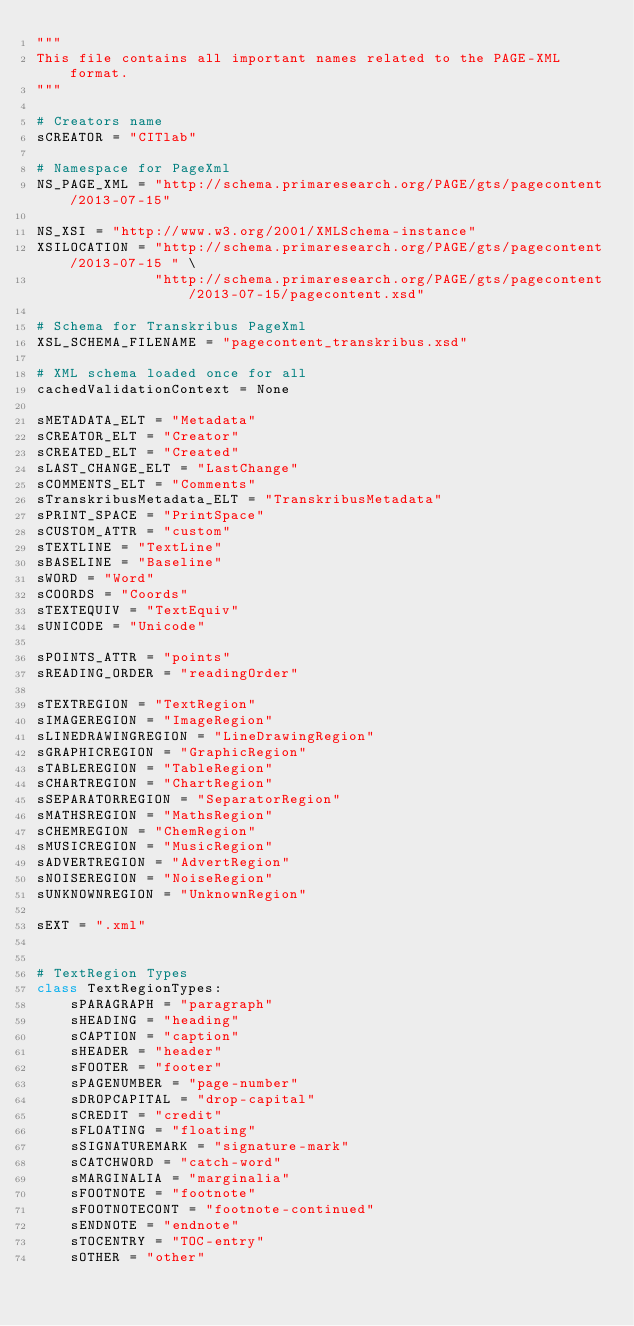Convert code to text. <code><loc_0><loc_0><loc_500><loc_500><_Python_>"""
This file contains all important names related to the PAGE-XML format.
"""

# Creators name
sCREATOR = "CITlab"

# Namespace for PageXml
NS_PAGE_XML = "http://schema.primaresearch.org/PAGE/gts/pagecontent/2013-07-15"

NS_XSI = "http://www.w3.org/2001/XMLSchema-instance"
XSILOCATION = "http://schema.primaresearch.org/PAGE/gts/pagecontent/2013-07-15 " \
              "http://schema.primaresearch.org/PAGE/gts/pagecontent/2013-07-15/pagecontent.xsd"

# Schema for Transkribus PageXml
XSL_SCHEMA_FILENAME = "pagecontent_transkribus.xsd"

# XML schema loaded once for all
cachedValidationContext = None

sMETADATA_ELT = "Metadata"
sCREATOR_ELT = "Creator"
sCREATED_ELT = "Created"
sLAST_CHANGE_ELT = "LastChange"
sCOMMENTS_ELT = "Comments"
sTranskribusMetadata_ELT = "TranskribusMetadata"
sPRINT_SPACE = "PrintSpace"
sCUSTOM_ATTR = "custom"
sTEXTLINE = "TextLine"
sBASELINE = "Baseline"
sWORD = "Word"
sCOORDS = "Coords"
sTEXTEQUIV = "TextEquiv"
sUNICODE = "Unicode"

sPOINTS_ATTR = "points"
sREADING_ORDER = "readingOrder"

sTEXTREGION = "TextRegion"
sIMAGEREGION = "ImageRegion"
sLINEDRAWINGREGION = "LineDrawingRegion"
sGRAPHICREGION = "GraphicRegion"
sTABLEREGION = "TableRegion"
sCHARTREGION = "ChartRegion"
sSEPARATORREGION = "SeparatorRegion"
sMATHSREGION = "MathsRegion"
sCHEMREGION = "ChemRegion"
sMUSICREGION = "MusicRegion"
sADVERTREGION = "AdvertRegion"
sNOISEREGION = "NoiseRegion"
sUNKNOWNREGION = "UnknownRegion"

sEXT = ".xml"


# TextRegion Types
class TextRegionTypes:
    sPARAGRAPH = "paragraph"
    sHEADING = "heading"
    sCAPTION = "caption"
    sHEADER = "header"
    sFOOTER = "footer"
    sPAGENUMBER = "page-number"
    sDROPCAPITAL = "drop-capital"
    sCREDIT = "credit"
    sFLOATING = "floating"
    sSIGNATUREMARK = "signature-mark"
    sCATCHWORD = "catch-word"
    sMARGINALIA = "marginalia"
    sFOOTNOTE = "footnote"
    sFOOTNOTECONT = "footnote-continued"
    sENDNOTE = "endnote"
    sTOCENTRY = "TOC-entry"
    sOTHER = "other"
</code> 